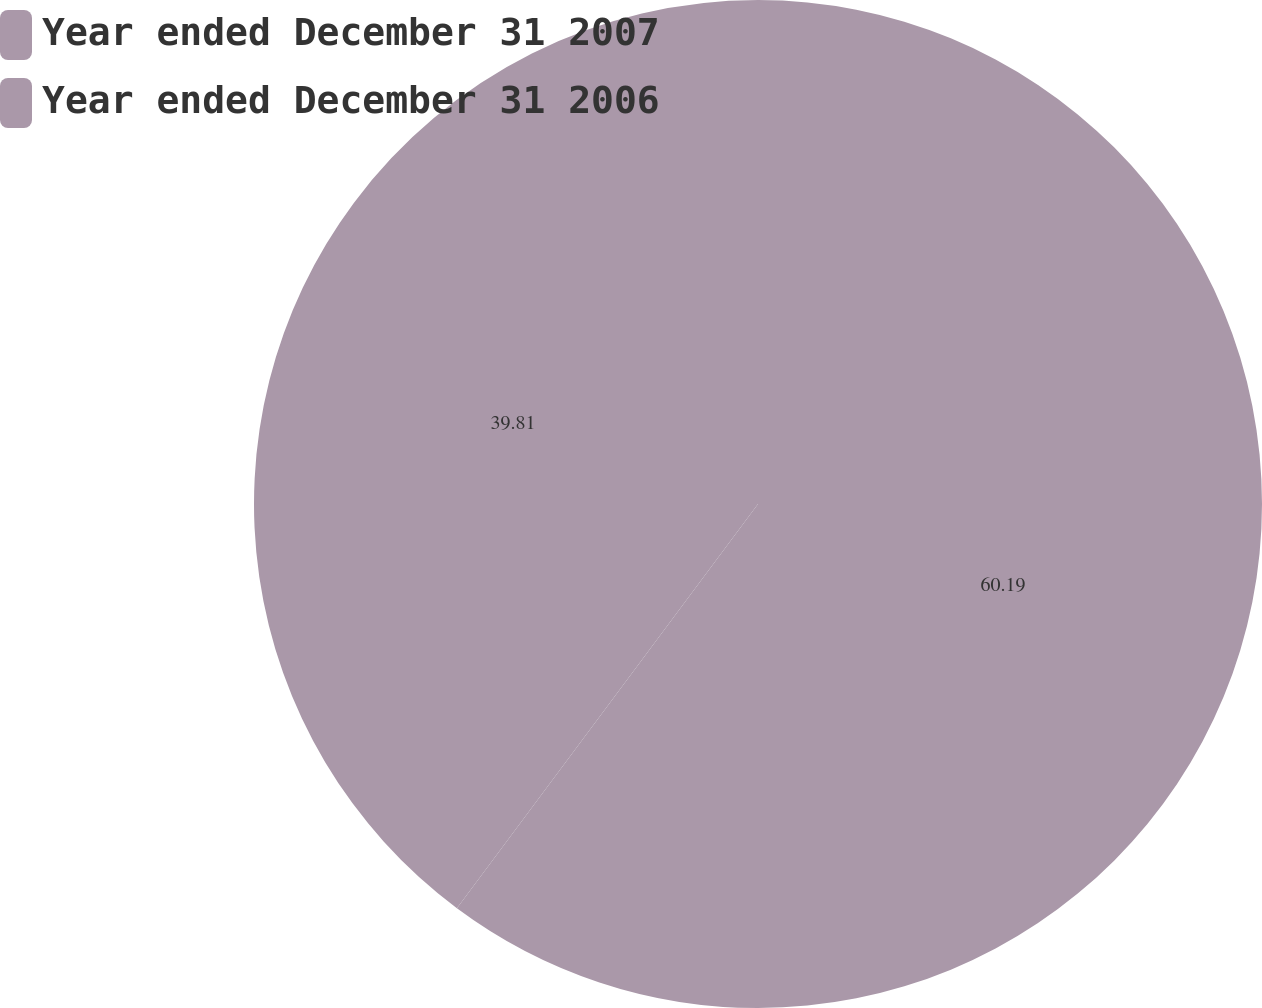Convert chart to OTSL. <chart><loc_0><loc_0><loc_500><loc_500><pie_chart><fcel>Year ended December 31 2007<fcel>Year ended December 31 2006<nl><fcel>60.19%<fcel>39.81%<nl></chart> 